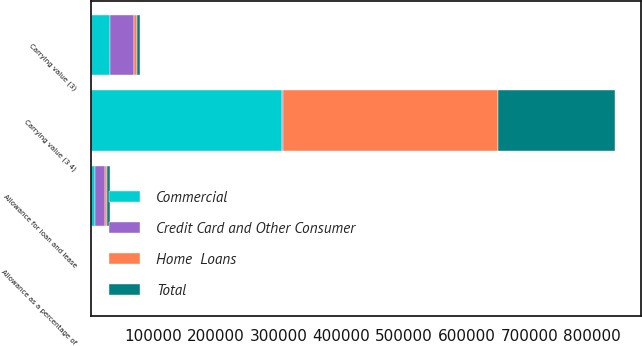Convert chart to OTSL. <chart><loc_0><loc_0><loc_500><loc_500><stacked_bar_chart><ecel><fcel>Allowance for loan and lease<fcel>Carrying value (3)<fcel>Allowance as a percentage of<fcel>Carrying value (3 4)<nl><fcel>Commercial<fcel>7697<fcel>30250<fcel>2.53<fcel>304701<nl><fcel>Total<fcel>5013<fcel>3881<fcel>2.67<fcel>187484<nl><fcel>Home  Loans<fcel>2776<fcel>4881<fcel>0.81<fcel>341502<nl><fcel>Credit Card and Other Consumer<fcel>15486<fcel>39012<fcel>1.86<fcel>2776<nl></chart> 